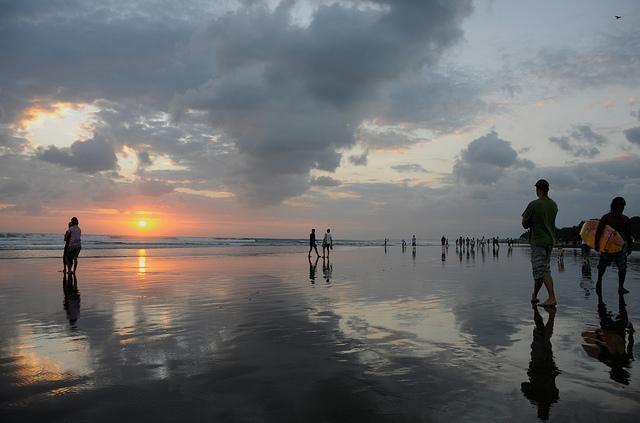How many cars are in the scene?
Give a very brief answer. 0. 